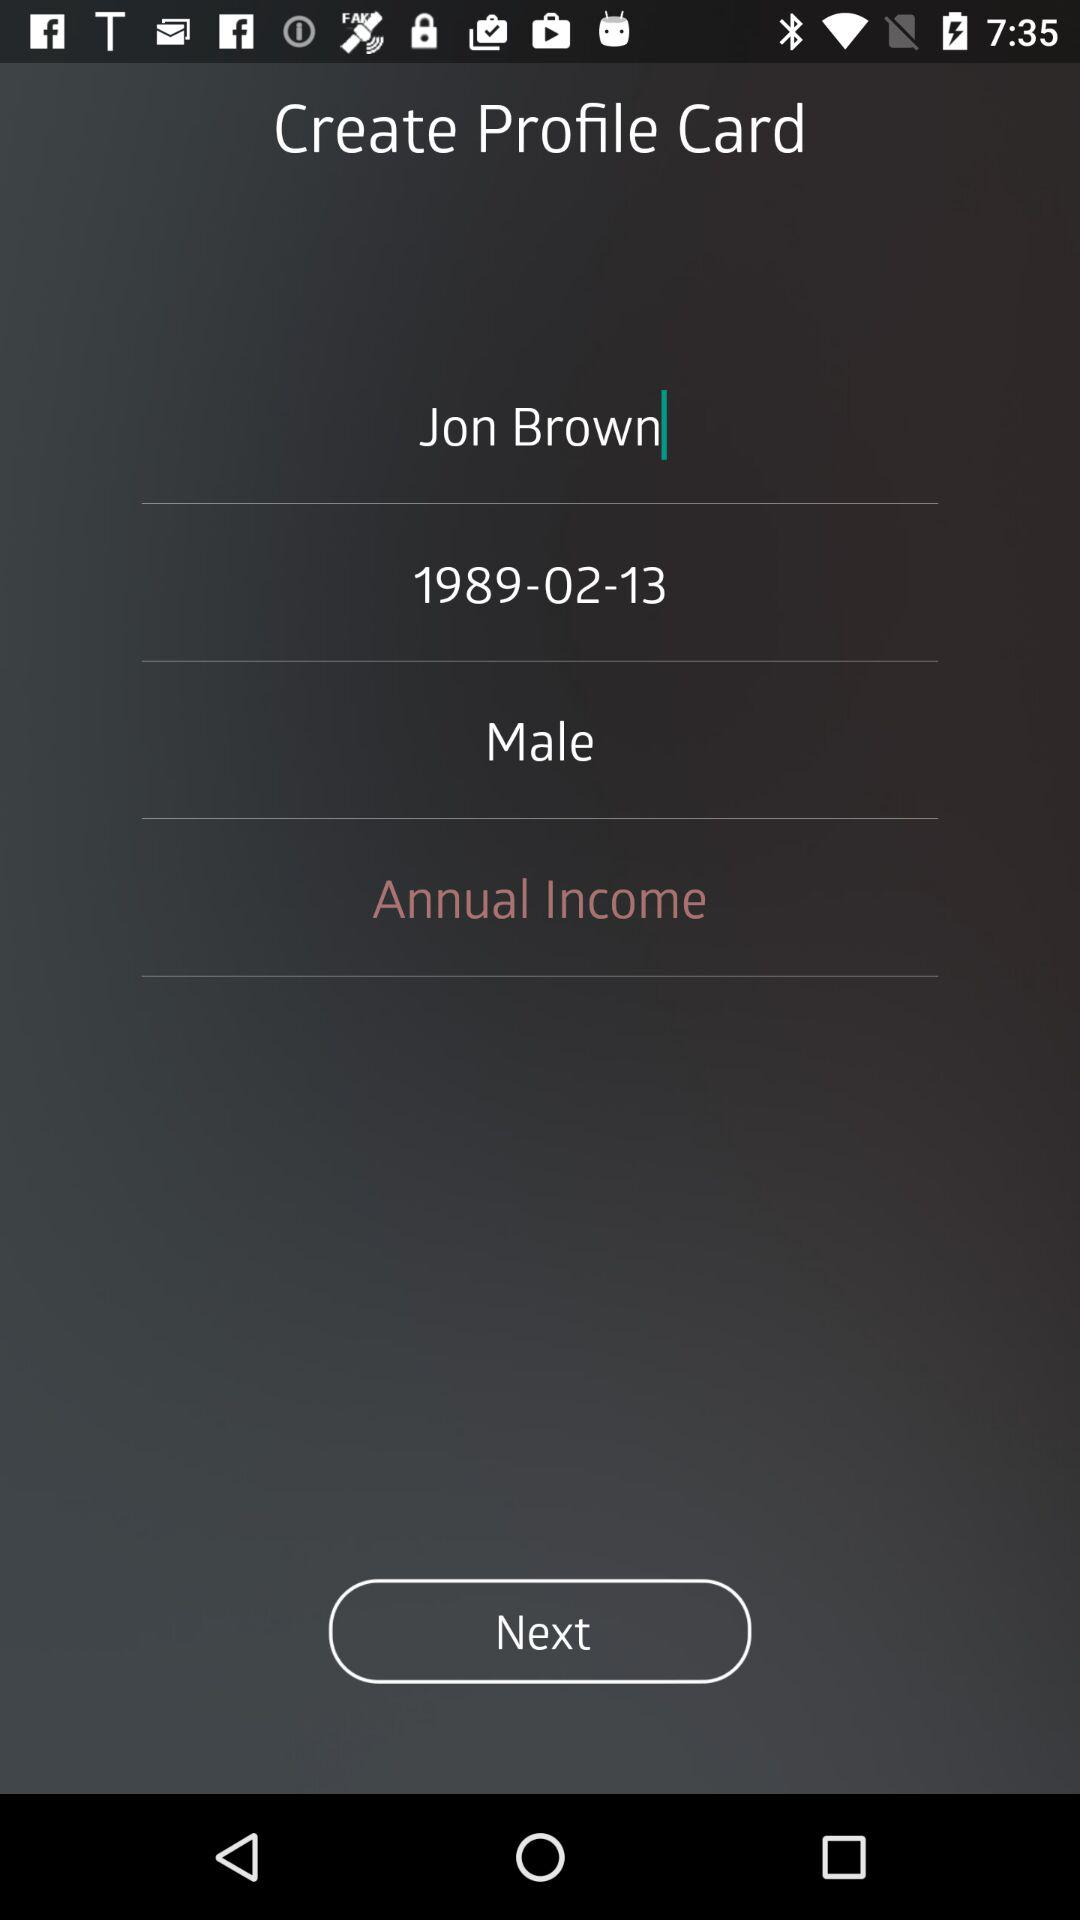What is the date of birth? The date of birth is February 13, 1989. 